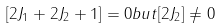<formula> <loc_0><loc_0><loc_500><loc_500>[ 2 J _ { 1 } + 2 J _ { 2 } + 1 ] = 0 b u t [ 2 J _ { 2 } ] \neq 0</formula> 